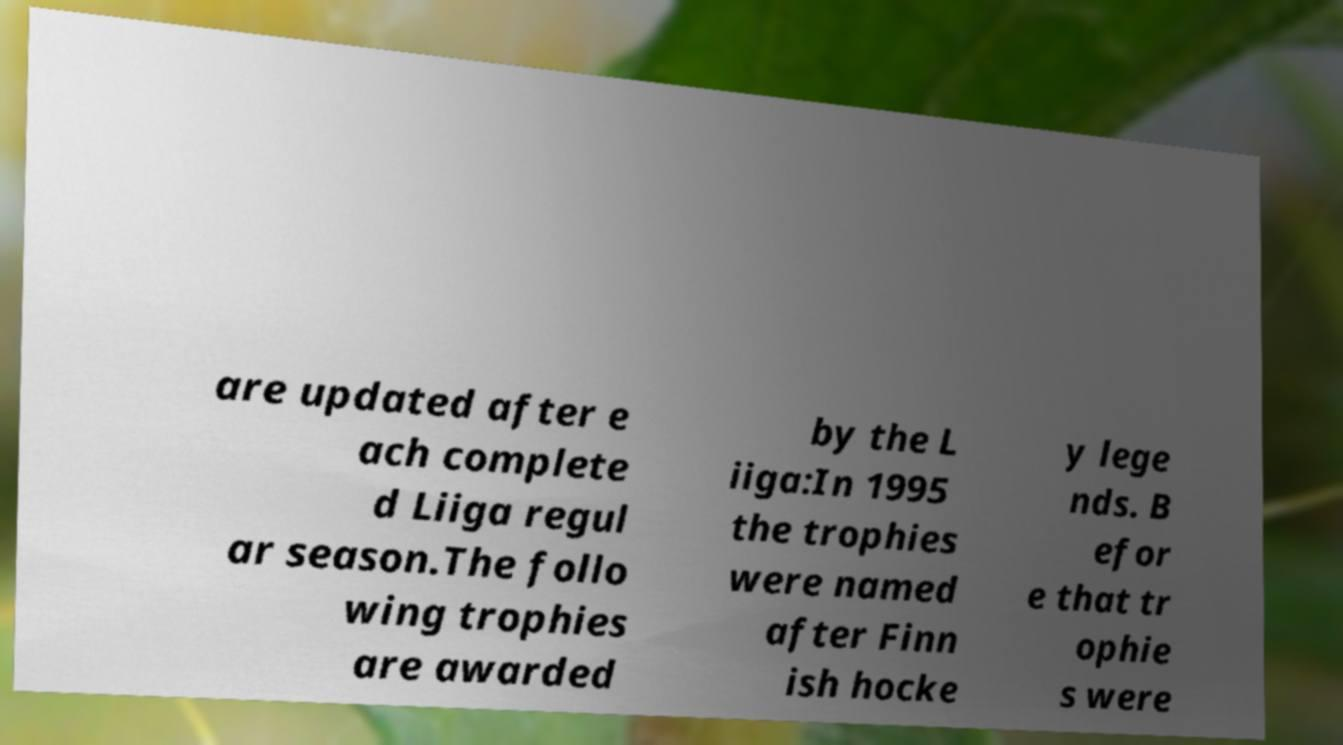Could you assist in decoding the text presented in this image and type it out clearly? are updated after e ach complete d Liiga regul ar season.The follo wing trophies are awarded by the L iiga:In 1995 the trophies were named after Finn ish hocke y lege nds. B efor e that tr ophie s were 